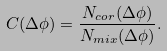<formula> <loc_0><loc_0><loc_500><loc_500>C ( \Delta \phi ) = \frac { N _ { c o r } ( \Delta \phi ) } { N _ { m i x } ( \Delta \phi ) } .</formula> 